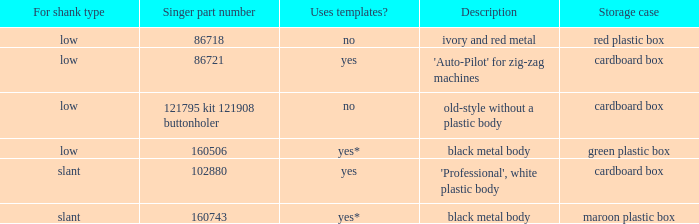What are all the different descriptions for the buttonholer with cardboard box for storage and a low shank type? 'Auto-Pilot' for zig-zag machines, old-style without a plastic body. 